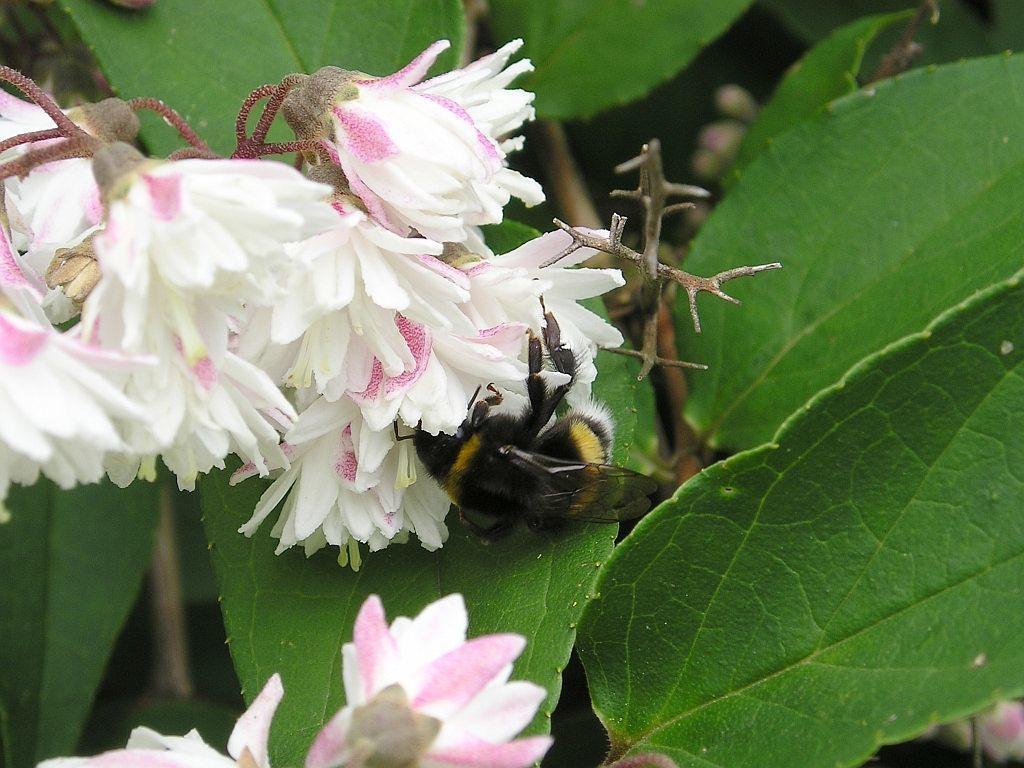Could you give a brief overview of what you see in this image? In this fly is on the flower. 